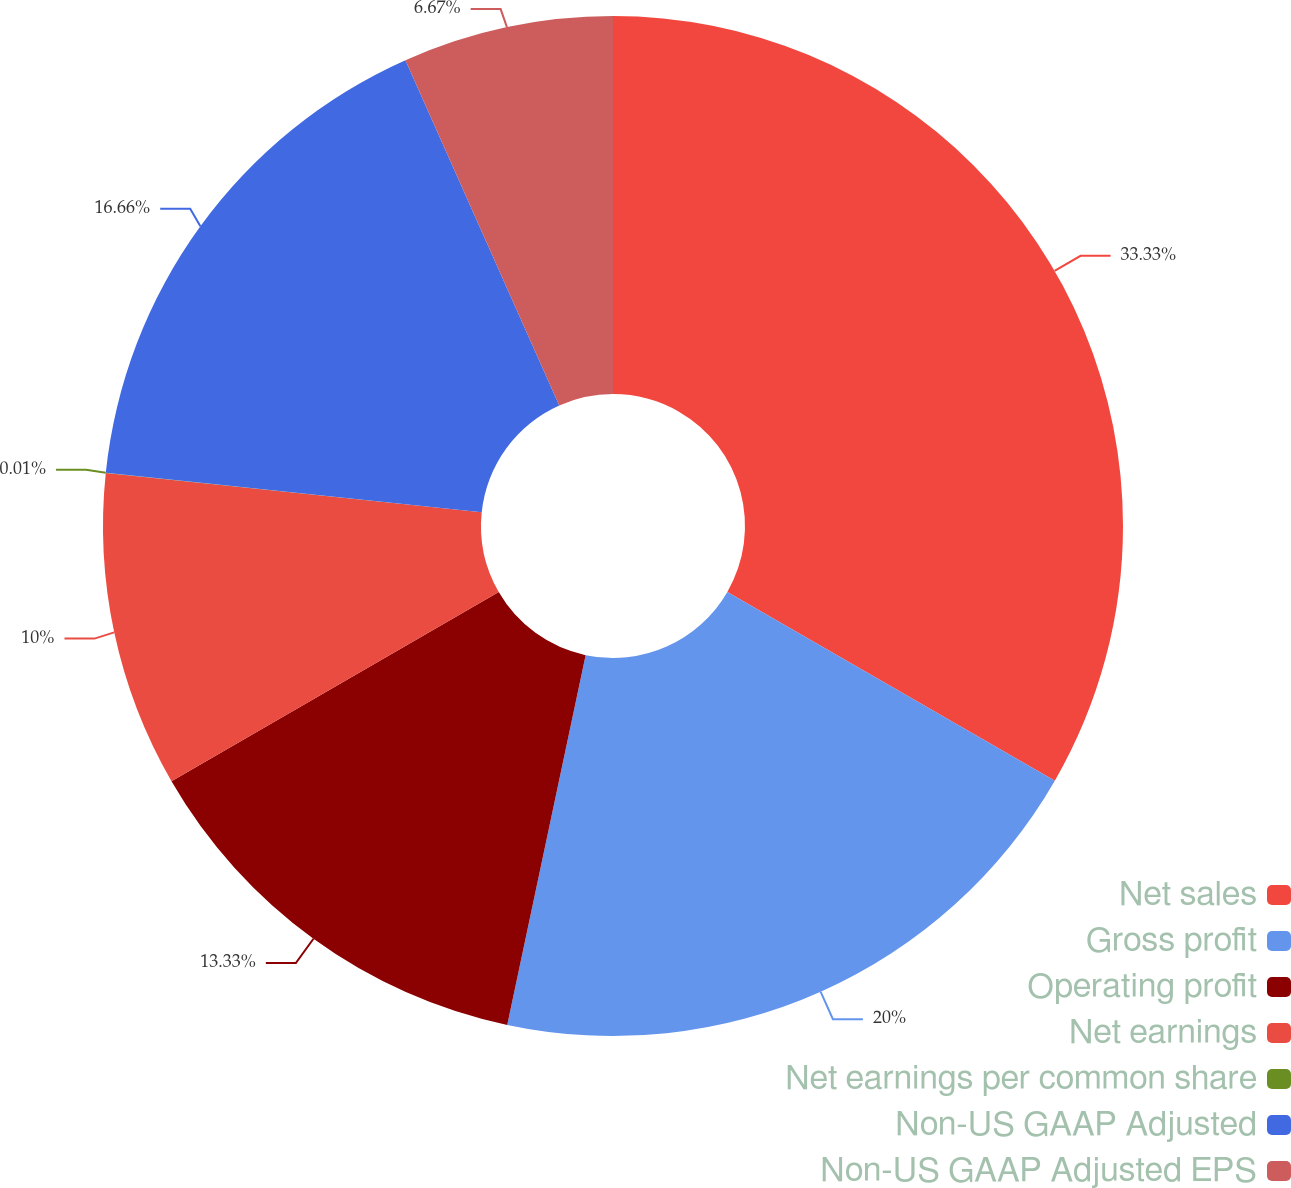Convert chart to OTSL. <chart><loc_0><loc_0><loc_500><loc_500><pie_chart><fcel>Net sales<fcel>Gross profit<fcel>Operating profit<fcel>Net earnings<fcel>Net earnings per common share<fcel>Non-US GAAP Adjusted<fcel>Non-US GAAP Adjusted EPS<nl><fcel>33.32%<fcel>20.0%<fcel>13.33%<fcel>10.0%<fcel>0.01%<fcel>16.66%<fcel>6.67%<nl></chart> 